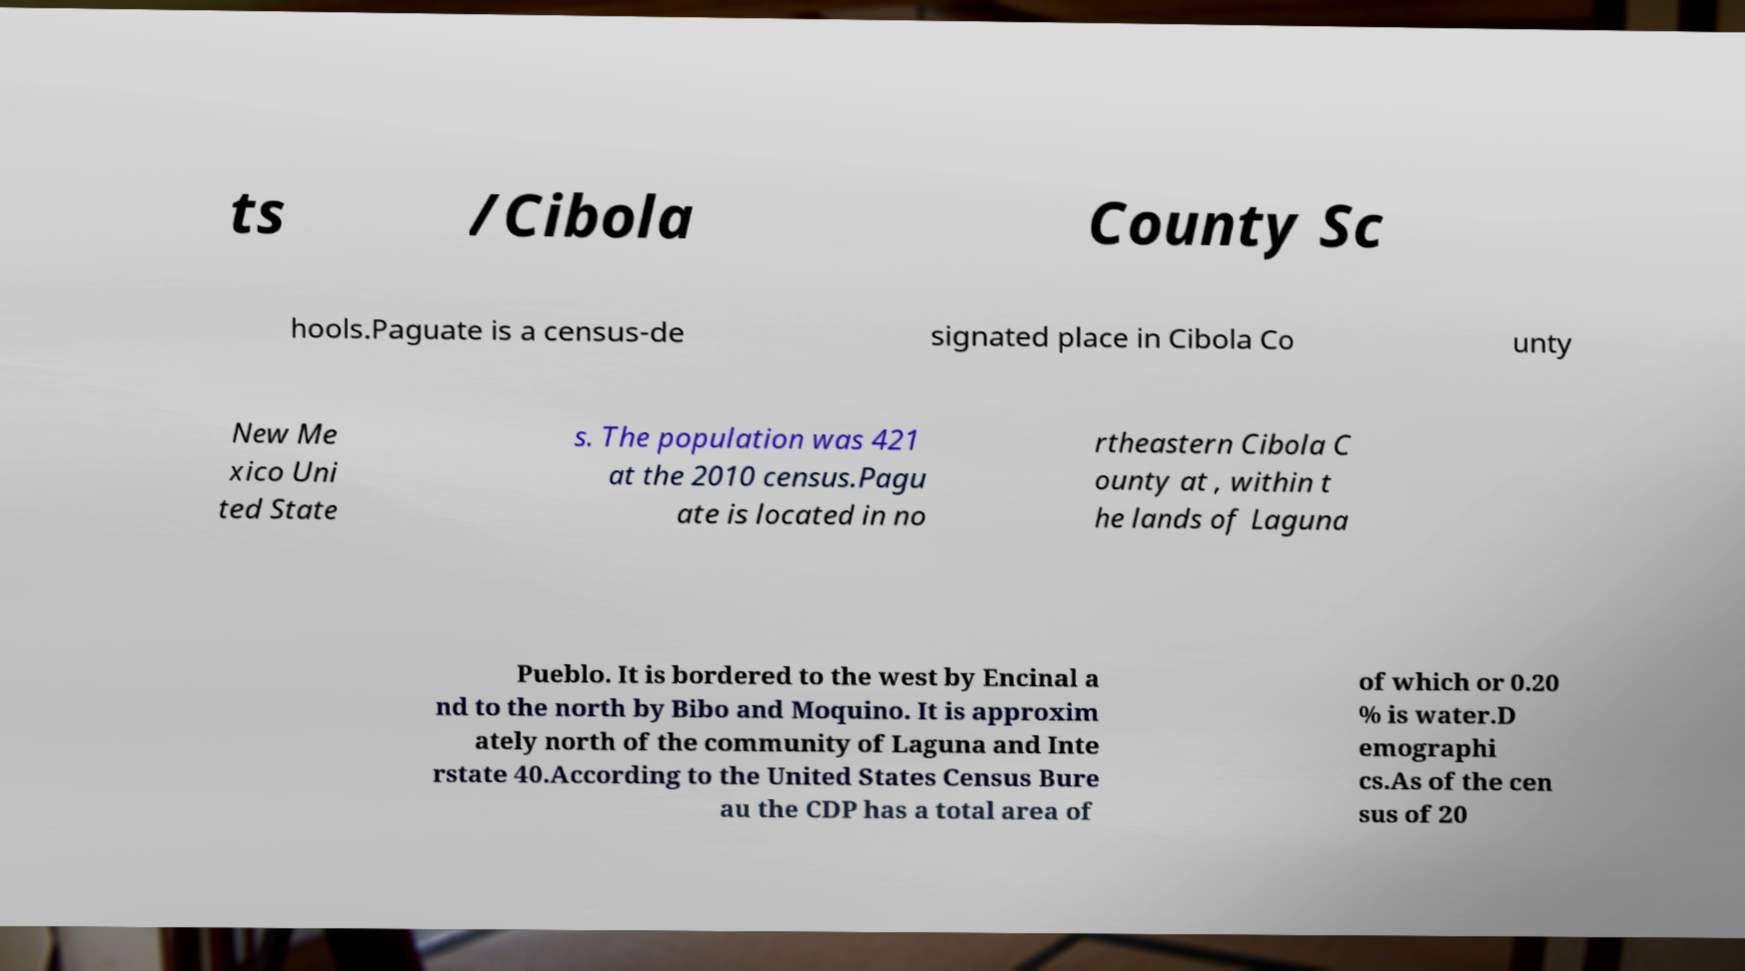Could you assist in decoding the text presented in this image and type it out clearly? ts /Cibola County Sc hools.Paguate is a census-de signated place in Cibola Co unty New Me xico Uni ted State s. The population was 421 at the 2010 census.Pagu ate is located in no rtheastern Cibola C ounty at , within t he lands of Laguna Pueblo. It is bordered to the west by Encinal a nd to the north by Bibo and Moquino. It is approxim ately north of the community of Laguna and Inte rstate 40.According to the United States Census Bure au the CDP has a total area of of which or 0.20 % is water.D emographi cs.As of the cen sus of 20 